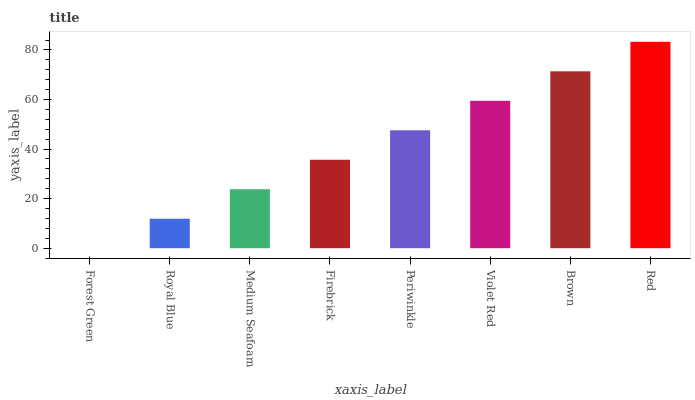Is Royal Blue the minimum?
Answer yes or no. No. Is Royal Blue the maximum?
Answer yes or no. No. Is Royal Blue greater than Forest Green?
Answer yes or no. Yes. Is Forest Green less than Royal Blue?
Answer yes or no. Yes. Is Forest Green greater than Royal Blue?
Answer yes or no. No. Is Royal Blue less than Forest Green?
Answer yes or no. No. Is Periwinkle the high median?
Answer yes or no. Yes. Is Firebrick the low median?
Answer yes or no. Yes. Is Forest Green the high median?
Answer yes or no. No. Is Medium Seafoam the low median?
Answer yes or no. No. 